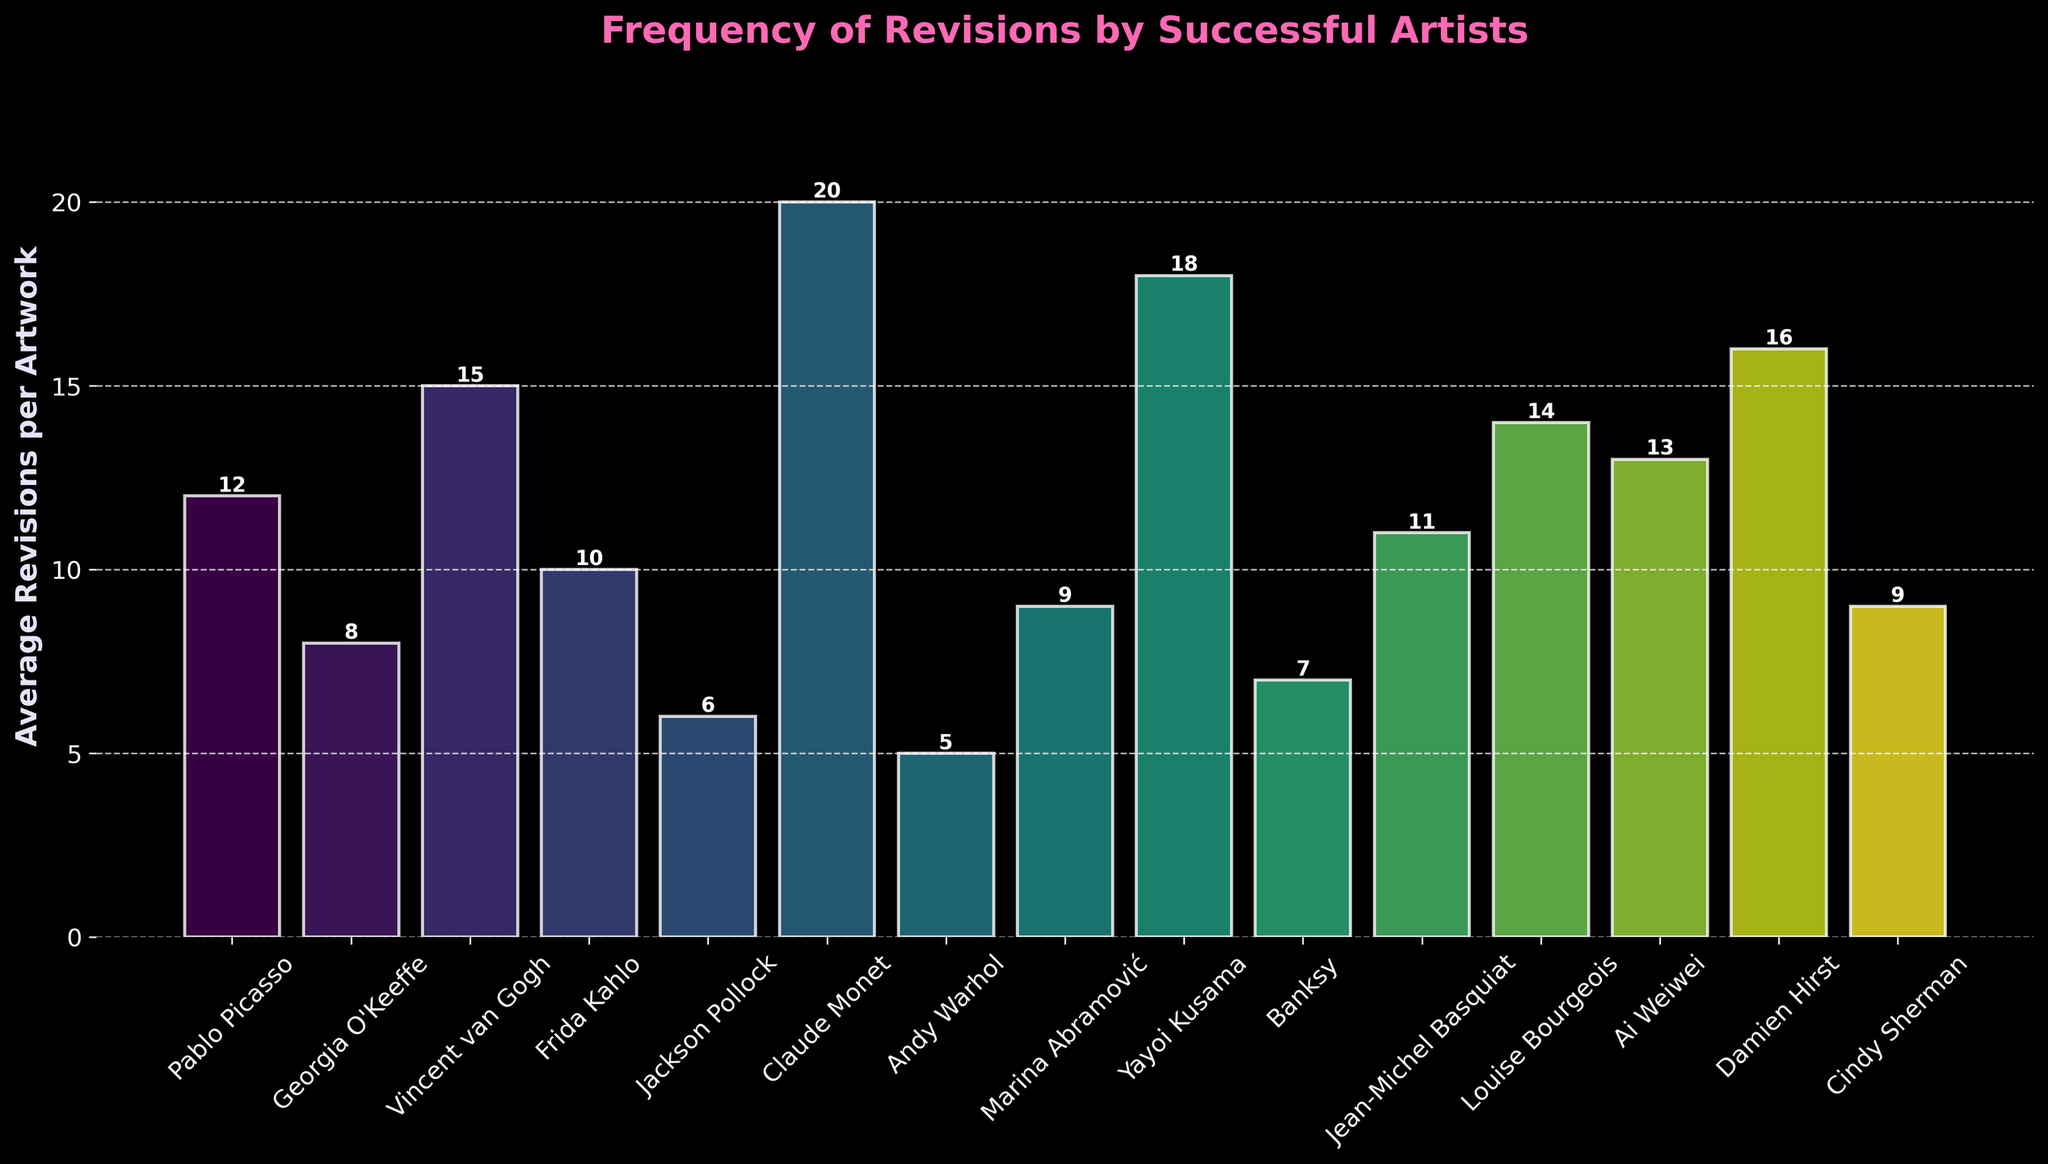Which artist has the highest average revisions per artwork? Claude Monet has the highest average revisions per artwork with 20 revisions. This can be determined by identifying the tallest bar in the chart.
Answer: Claude Monet Which artist has fewer average revisions per artwork: Banksy or Frida Kahlo? Frida Kahlo has 10 average revisions, while Banksy has 7. Since 7 is less than 10, Banksy has fewer average revisions per artwork.
Answer: Banksy What is the combined total average revisions for Ai Weiwei and Jackson Pollock? Ai Weiwei has 13 average revisions, and Jackson Pollock has 6 average revisions. Adding these together gives 13 + 6 = 19.
Answer: 19 Are there more artists with an average of 10 or more revisions per artwork than those with fewer than 10? Count the artists with an average of 10 or more revisions (Pablo Picasso, Vincent van Gogh, Frida Kahlo, Claude Monet, Yayoi Kusama, Jean-Michel Basquiat, Louise Bourgeois, Ai Weiwei, Damien Hirst, nine artists). Count those with fewer than 10 revisions (Georgia O'Keeffe, Jackson Pollock, Andy Warhol, Marina Abramović, Banksy, Cindy Sherman, six artists). Since 9 > 6, there are more artists with an average of 10 or more revisions.
Answer: More What is the average number of revisions per artwork across all the artists shown? Sum all the revisions: 12 + 8 + 15 + 10 + 6 + 20 + 5 + 9 + 18 + 7 + 11 + 14 + 13 + 16 + 9 = 173. Divide by the number of artists, which is 15. So the average is 173 / 15 ≈ 11.53.
Answer: 11.53 Which two artists have bars with the closest heights, representing similar average revisions per artwork? The closest average revisions are between Frida Kahlo (10) and Marina Abramović (9). This can be determined by visually comparing the heights of their bars and noting the smallest difference.
Answer: Frida Kahlo and Marina Abramović How much taller is Claude Monet’s bar compared to Andy Warhol’s bar? Claude Monet's bar represents 20 revisions, and Andy Warhol's bar represents 5 revisions. The difference is 20 - 5 = 15.
Answer: 15 By how much does Yayoi Kusama's average revisions exceed Georgia O'Keeffe’s average revisions? Yayoi Kusama has 18 average revisions, and Georgia O'Keeffe has 8. The difference is 18 - 8 = 10.
Answer: 10 